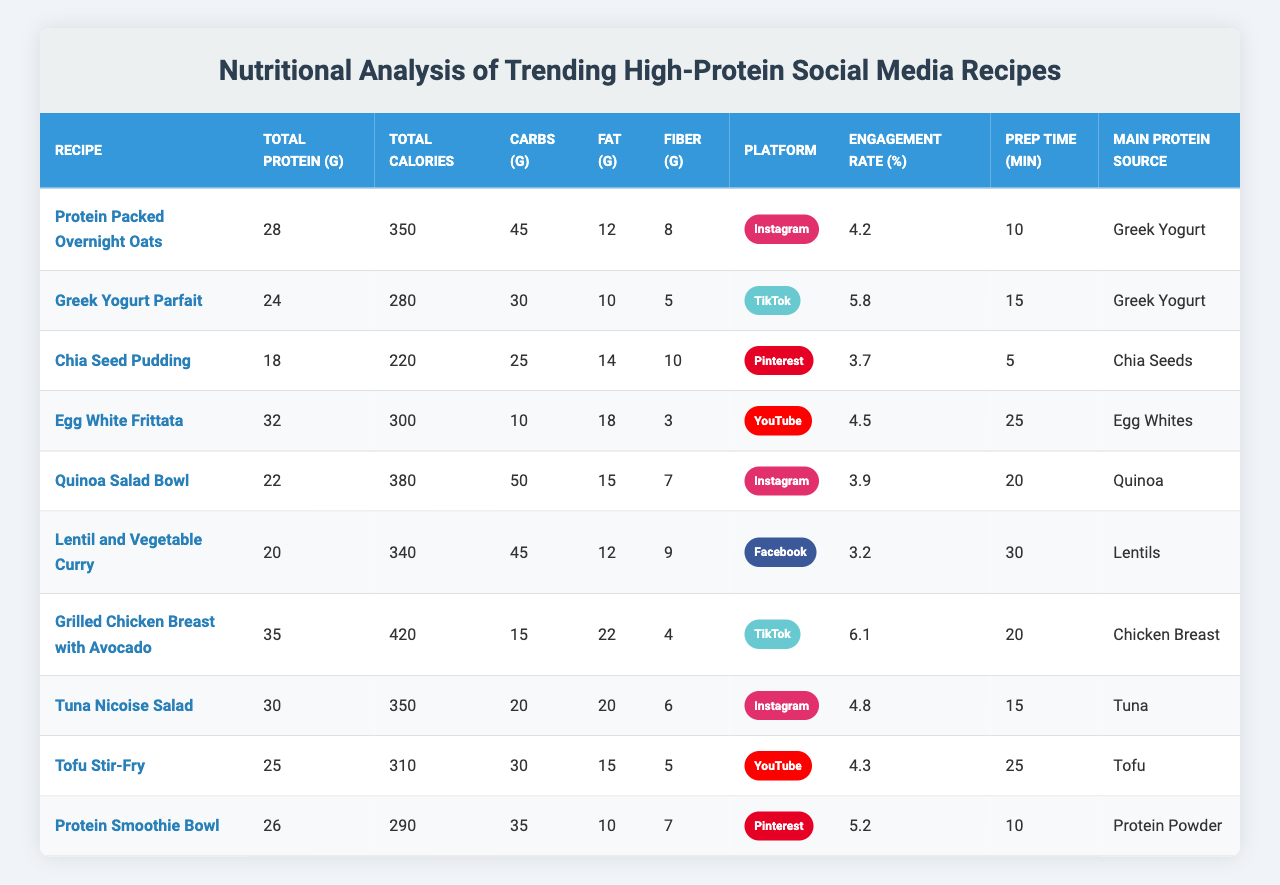What is the total protein content in the "Grilled Chicken Breast with Avocado" recipe? The table shows that "Grilled Chicken Breast with Avocado" has a total protein content of 35 grams listed under the "Total Protein (g)" column.
Answer: 35 grams Which recipe has the highest engagement rate? By examining the "Engagement Rate (%)" column, "Grilled Chicken Breast with Avocado" has the highest engagement rate at 6.1%.
Answer: 6.1% What is the carbohydrate content of the "Protein Smoothie Bowl"? The carbohydrate content for the "Protein Smoothie Bowl" is found in the "Carbohydrate Content (g)" column, which indicates it has 35 grams of carbohydrates.
Answer: 35 grams Is the fat content in "Chia Seed Pudding" greater than that in "Egg White Frittata"? The fat content for "Chia Seed Pudding" is 14 grams, while for "Egg White Frittata," it is 18 grams. Since 14 is less than 18, the statement is false.
Answer: No What is the average preparation time for the recipes? To find the average preparation time, add all the times together (10 + 15 + 5 + 25 + 20 + 30 + 20 + 15 + 25 + 10 = 175 minutes), then divide by the number of recipes (10): 175/10 = 17.5 minutes.
Answer: 17.5 minutes How many recipes contain Greek Yogurt as the main protein source? From the "Main Protein Source" column, both "Protein Packed Overnight Oats" and "Greek Yogurt Parfait" contain Greek Yogurt, which totals 2 recipes.
Answer: 2 recipes What is the total calorie difference between "Lentil and Vegetable Curry" and "Quinoa Salad Bowl"? Check the "Total Calories" for each recipe: "Lentil and Vegetable Curry" has 340 calories and "Quinoa Salad Bowl" has 380. Subtract 340 from 380 to get a difference of 40 calories.
Answer: 40 calories Which recipe has the lowest fiber content, and what is that value? The "Fiber Content (g)" column shows "Egg White Frittata" with a fiber content of 3 grams, which is the lowest among all recipes.
Answer: 3 grams What is the total protein content across all recipes? To find total protein, sum the protein values: (28 + 24 + 18 + 32 + 22 + 20 + 35 + 30 + 25 + 26 =  260 grams).
Answer: 260 grams Is the carbohydrate content in "Tuna Nicoise Salad" greater than that in "Tofu Stir-Fry"? The carbohydrate content for "Tuna Nicoise Salad" is 20 grams and for "Tofu Stir-Fry" it is 30 grams. Since 20 is less than 30, the statement is false.
Answer: No 